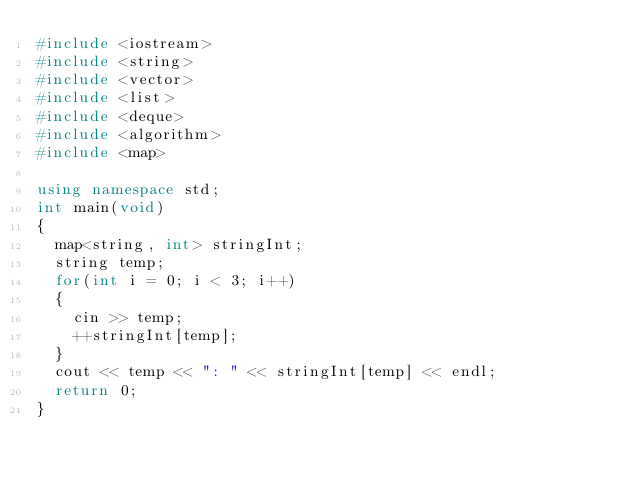<code> <loc_0><loc_0><loc_500><loc_500><_C++_>#include <iostream>
#include <string>
#include <vector>
#include <list>
#include <deque>
#include <algorithm>
#include <map>

using namespace std;
int main(void)
{
	map<string, int> stringInt;
	string temp;
	for(int i = 0; i < 3; i++)
	{
		cin >> temp;
		++stringInt[temp];
	}
	cout << temp << ": " << stringInt[temp] << endl;
	return 0;
}
</code> 